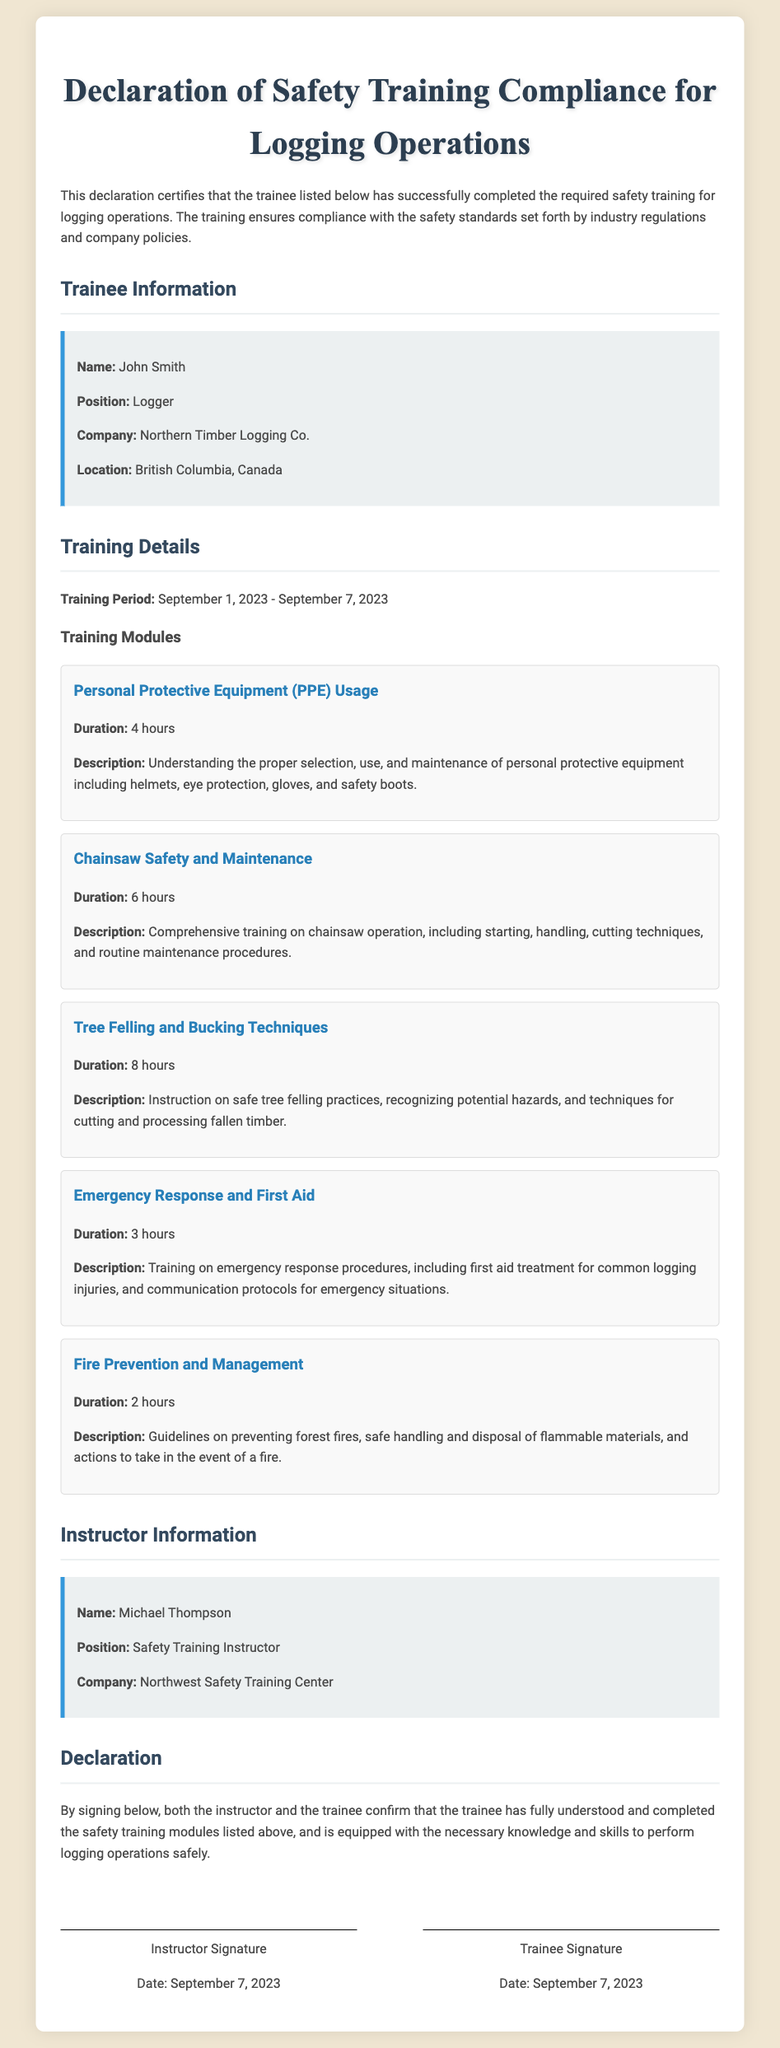What is the name of the trainee? The trainee's name is listed in the document under Trainee Information.
Answer: John Smith What is the training period? The training period can be found in the Training Details section of the document.
Answer: September 1, 2023 - September 7, 2023 How many hours was the Chainsaw Safety and Maintenance module? The duration for this module is mentioned in the Training Modules section of the document.
Answer: 6 hours What is the name of the instructor? The instructor's name is provided in the Instructor Information section of the document.
Answer: Michael Thompson How many training modules were covered? This information can be counted from the listed training modules in the document.
Answer: 5 modules What is the position of the trainee? The trainee's position is specified in the Trainee Information section of the document.
Answer: Logger What date was the declaration signed? The signing date can be found in the signature area of the document.
Answer: September 7, 2023 What is the description of the Fire Prevention and Management module? This description is provided in the Training Modules section, outlining the training's focus.
Answer: Guidelines on preventing forest fires, safe handling and disposal of flammable materials, and actions to take in the event of a fire What company is the trainee associated with? The trainee's company is listed in the Trainee Information section of the document.
Answer: Northern Timber Logging Co 